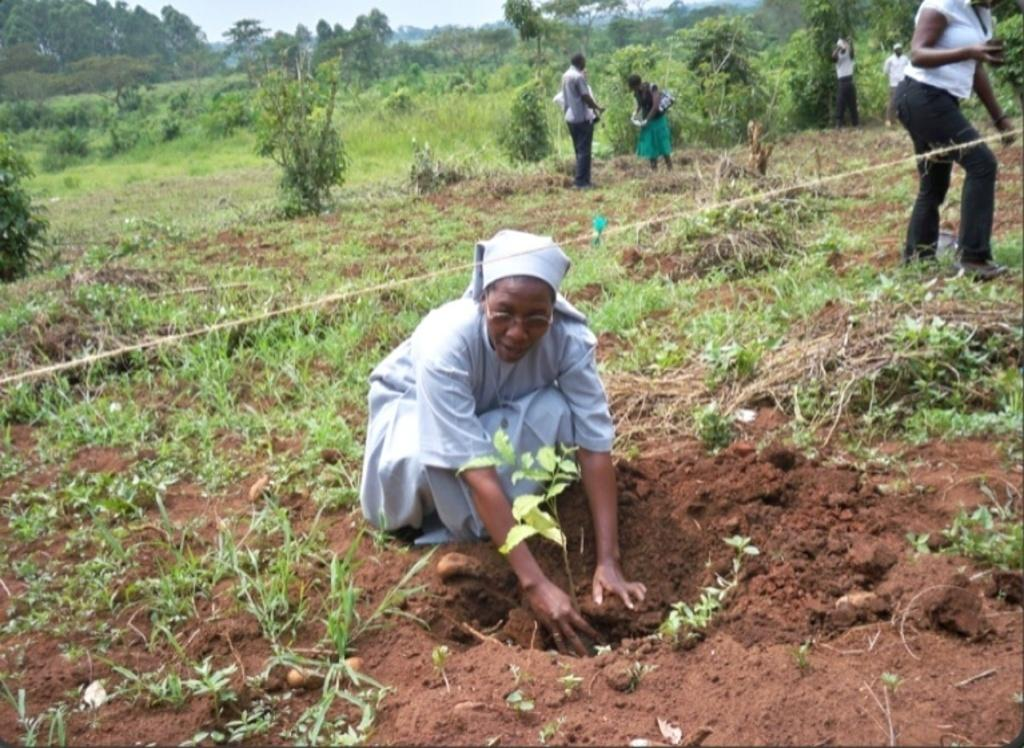How many people are in the image? There are people in the image, but the exact number is not specified. What is one person doing in the image? One person is planting in the soil in the image. What type of living organisms can be seen in the image? Plants and trees are visible in the image. What is the texture of the ground in the image? The ground in the image is covered with grass. What is visible in the background of the image? Trees and the sky are visible in the background of the image. What type of drum can be heard playing in the background of the image? There is no drum or sound present in the image; it is a visual representation only. 